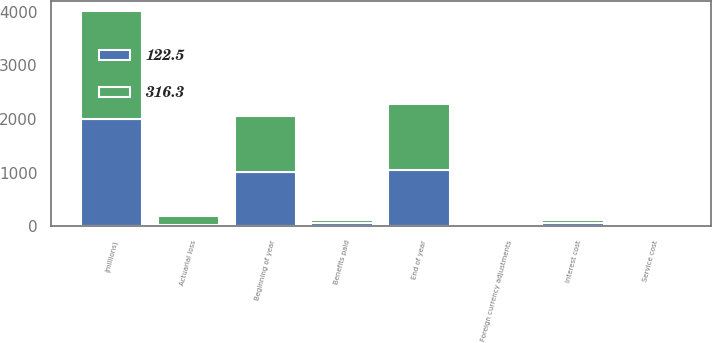Convert chart. <chart><loc_0><loc_0><loc_500><loc_500><stacked_bar_chart><ecel><fcel>(millions)<fcel>Beginning of year<fcel>Service cost<fcel>Interest cost<fcel>Actuarial loss<fcel>Benefits paid<fcel>Foreign currency adjustments<fcel>End of year<nl><fcel>316.3<fcel>2005<fcel>1046.7<fcel>14.5<fcel>58.3<fcel>164.6<fcel>60.4<fcel>1.2<fcel>1224.9<nl><fcel>122.5<fcel>2004<fcel>1006.6<fcel>12.1<fcel>55.6<fcel>24.3<fcel>53.9<fcel>2<fcel>1046.7<nl></chart> 